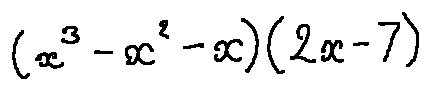Convert formula to latex. <formula><loc_0><loc_0><loc_500><loc_500>( x ^ { 3 } - x ^ { 2 } - x ) ( 2 x - 7 )</formula> 